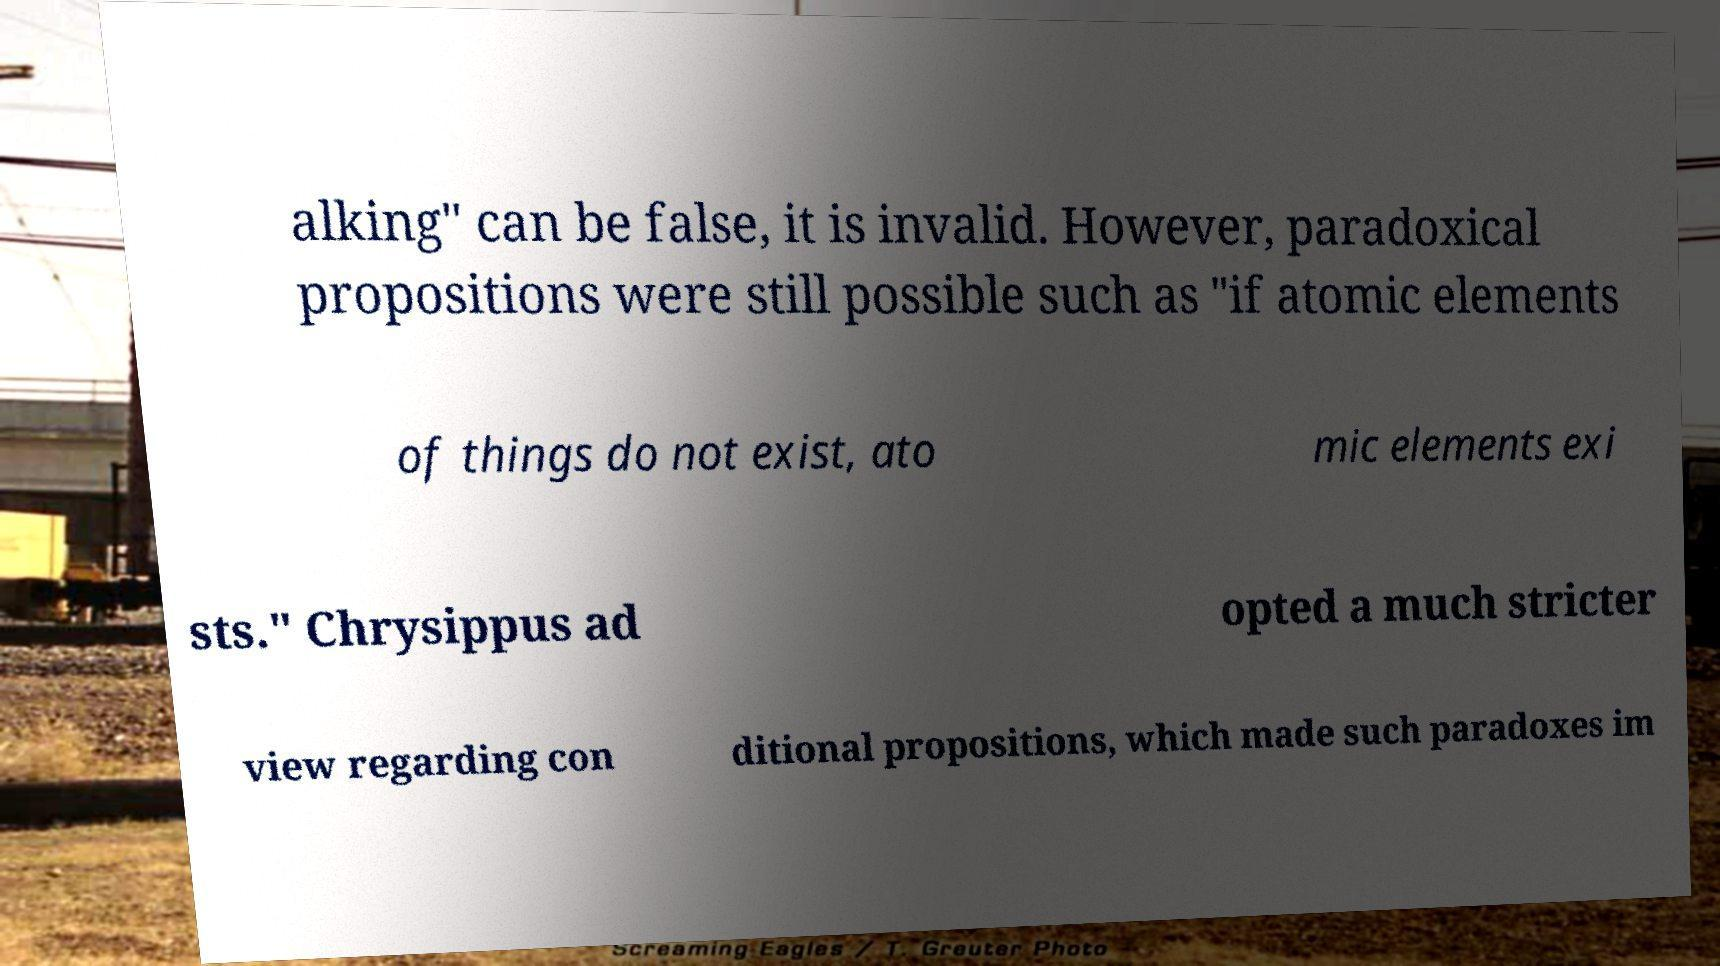Can you accurately transcribe the text from the provided image for me? alking" can be false, it is invalid. However, paradoxical propositions were still possible such as "if atomic elements of things do not exist, ato mic elements exi sts." Chrysippus ad opted a much stricter view regarding con ditional propositions, which made such paradoxes im 